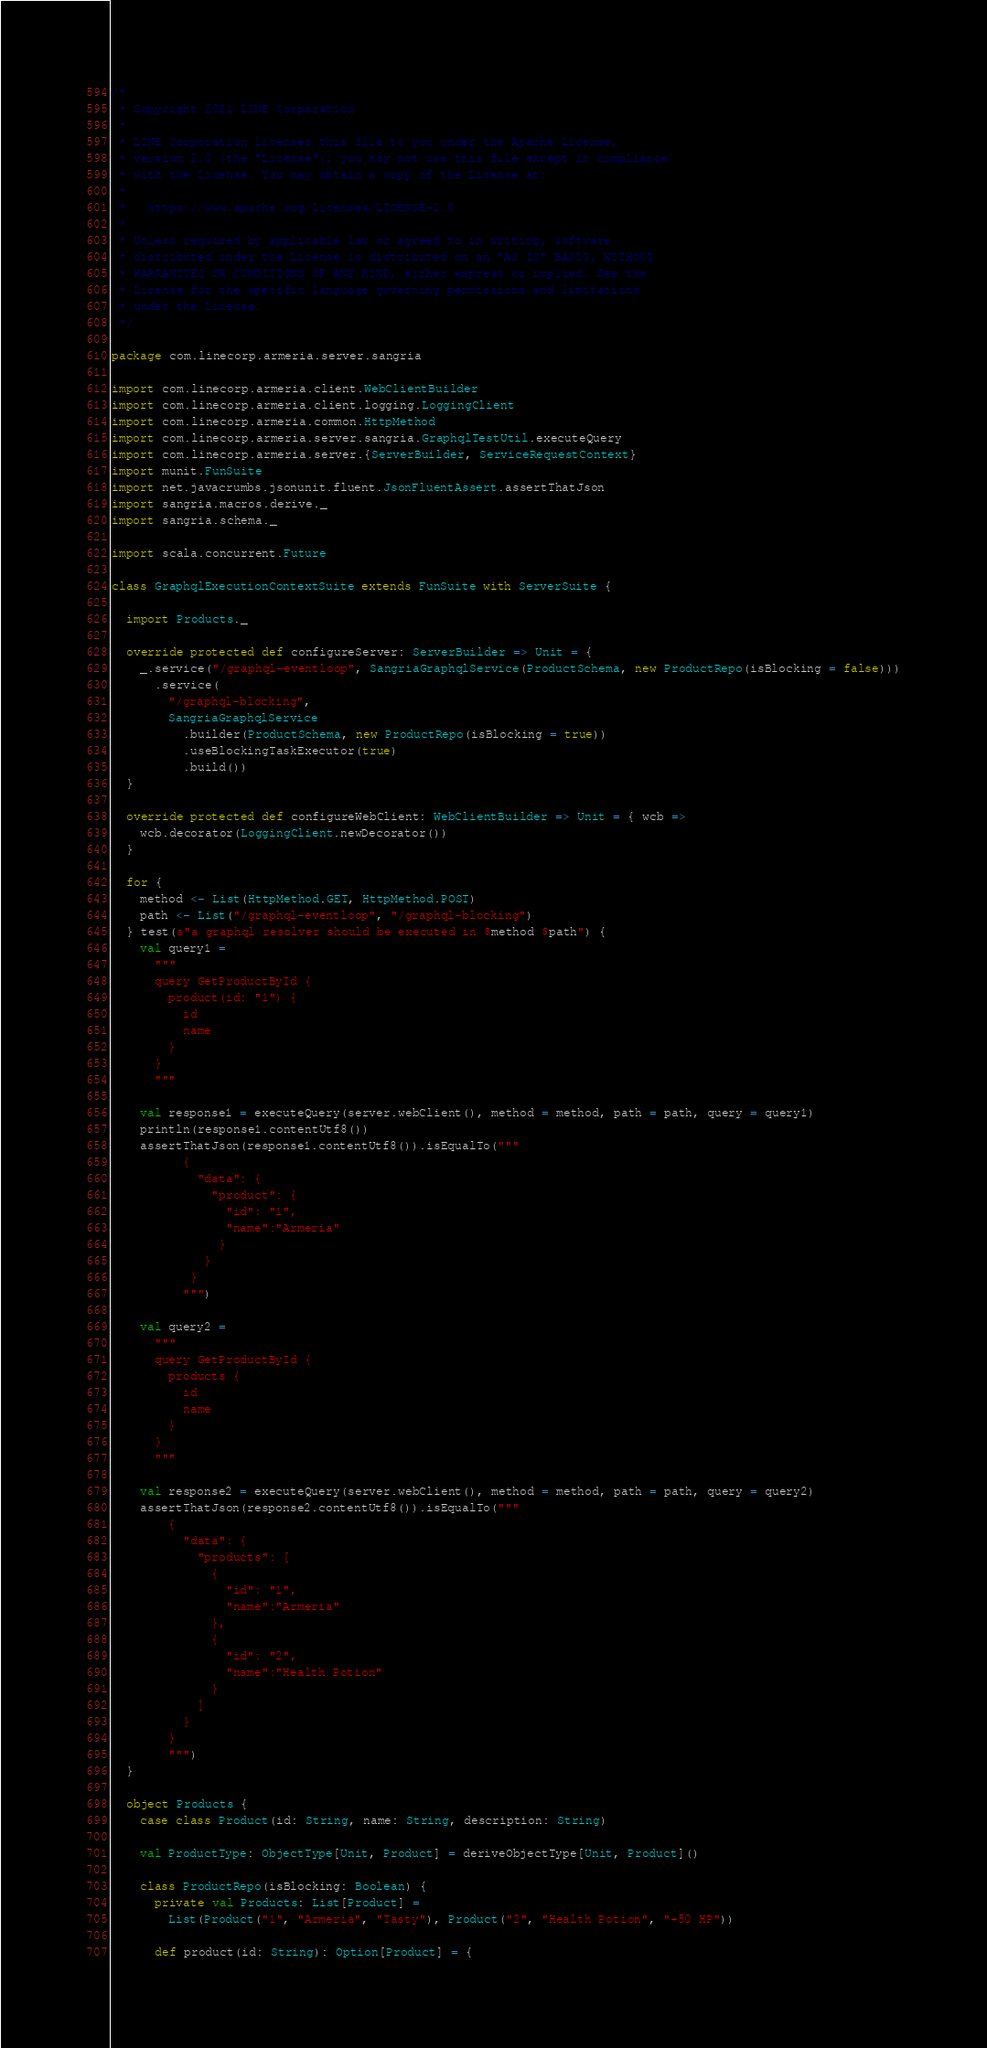<code> <loc_0><loc_0><loc_500><loc_500><_Scala_>/*
 * Copyright 2021 LINE Corporation
 *
 * LINE Corporation licenses this file to you under the Apache License,
 * version 2.0 (the "License"); you may not use this file except in compliance
 * with the License. You may obtain a copy of the License at:
 *
 *   https://www.apache.org/licenses/LICENSE-2.0
 *
 * Unless required by applicable law or agreed to in writing, software
 * distributed under the License is distributed on an "AS IS" BASIS, WITHOUT
 * WARRANTIES OR CONDITIONS OF ANY KIND, either express or implied. See the
 * License for the specific language governing permissions and limitations
 * under the License.
 */

package com.linecorp.armeria.server.sangria

import com.linecorp.armeria.client.WebClientBuilder
import com.linecorp.armeria.client.logging.LoggingClient
import com.linecorp.armeria.common.HttpMethod
import com.linecorp.armeria.server.sangria.GraphqlTestUtil.executeQuery
import com.linecorp.armeria.server.{ServerBuilder, ServiceRequestContext}
import munit.FunSuite
import net.javacrumbs.jsonunit.fluent.JsonFluentAssert.assertThatJson
import sangria.macros.derive._
import sangria.schema._

import scala.concurrent.Future

class GraphqlExecutionContextSuite extends FunSuite with ServerSuite {

  import Products._

  override protected def configureServer: ServerBuilder => Unit = {
    _.service("/graphql-eventloop", SangriaGraphqlService(ProductSchema, new ProductRepo(isBlocking = false)))
      .service(
        "/graphql-blocking",
        SangriaGraphqlService
          .builder(ProductSchema, new ProductRepo(isBlocking = true))
          .useBlockingTaskExecutor(true)
          .build())
  }

  override protected def configureWebClient: WebClientBuilder => Unit = { wcb =>
    wcb.decorator(LoggingClient.newDecorator())
  }

  for {
    method <- List(HttpMethod.GET, HttpMethod.POST)
    path <- List("/graphql-eventloop", "/graphql-blocking")
  } test(s"a graphql resolver should be executed in $method $path") {
    val query1 =
      """
      query GetProductById {
        product(id: "1") {
          id
          name
        }
      }
      """

    val response1 = executeQuery(server.webClient(), method = method, path = path, query = query1)
    println(response1.contentUtf8())
    assertThatJson(response1.contentUtf8()).isEqualTo("""
          {
            "data": {
              "product": {
                "id": "1",
                "name":"Armeria"
               }
             }
           }
          """)

    val query2 =
      """
      query GetProductById {
        products {
          id
          name
        }
      }
      """

    val response2 = executeQuery(server.webClient(), method = method, path = path, query = query2)
    assertThatJson(response2.contentUtf8()).isEqualTo("""
        {
          "data": {
            "products": [
              {
                "id": "1",
                "name":"Armeria"
              },
              {
                "id": "2",
                "name":"Health Potion"
              }
            ]
          }
        }
        """)
  }

  object Products {
    case class Product(id: String, name: String, description: String)

    val ProductType: ObjectType[Unit, Product] = deriveObjectType[Unit, Product]()

    class ProductRepo(isBlocking: Boolean) {
      private val Products: List[Product] =
        List(Product("1", "Armeria", "Tasty"), Product("2", "Health Potion", "+50 HP"))

      def product(id: String): Option[Product] = {</code> 